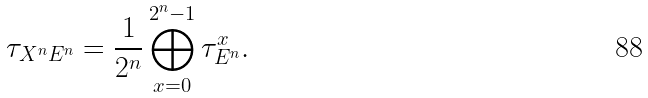<formula> <loc_0><loc_0><loc_500><loc_500>\tau _ { X ^ { n } E ^ { n } } = \frac { 1 } { 2 ^ { n } } \bigoplus _ { x = 0 } ^ { 2 ^ { n } - 1 } \tau _ { E ^ { n } } ^ { x } .</formula> 